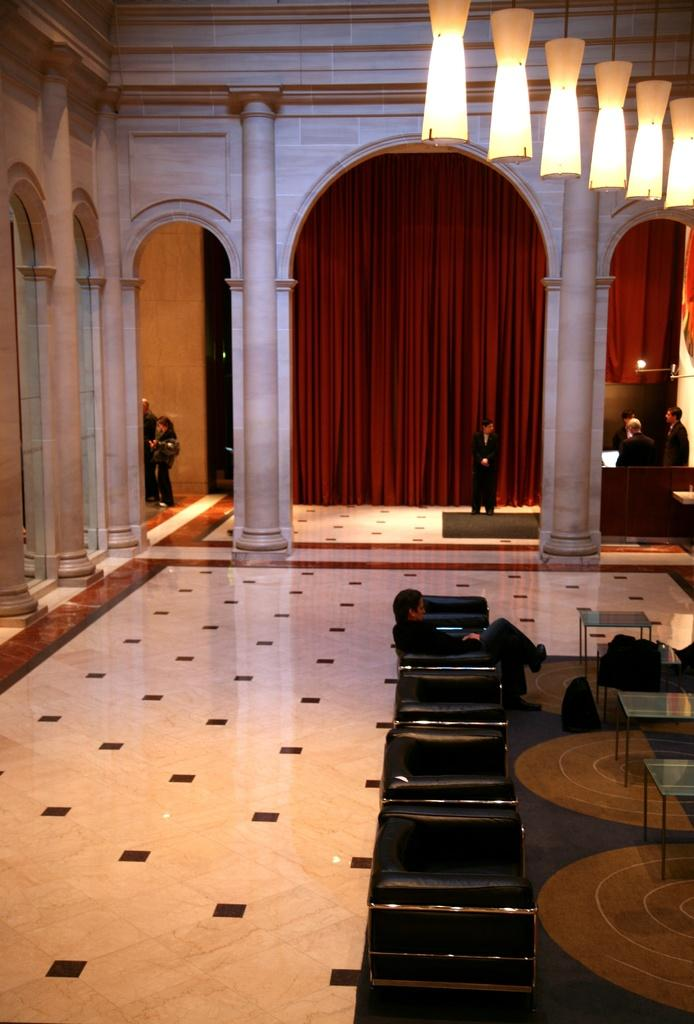What is the man in the image doing? The man is sitting on a chair in the image. Are there any other chairs visible in the image? Yes, there are chairs in front of the man. What can be seen in the background of the image? There is a pillar in the background of the image. What type of covering is present in the image? There is a curtain in the image. What is the source of light visible at the top of the image? There is a light visible at the top of the image. What type of van is parked in front of the man in the image? There is no van present in the image; it only features a man sitting on a chair, chairs, a pillar, a curtain, and a light. 